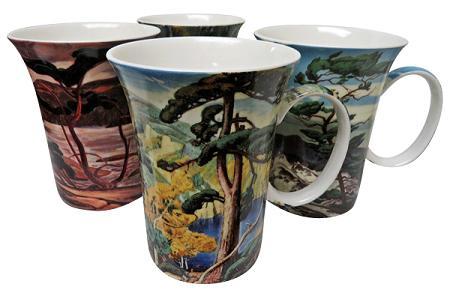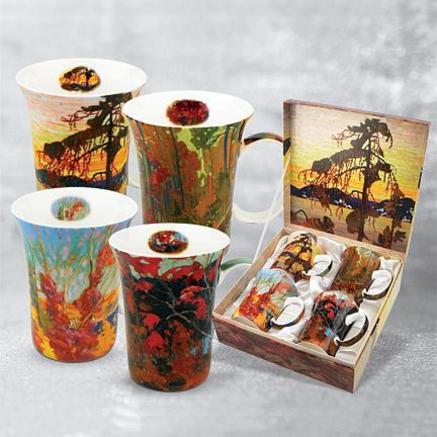The first image is the image on the left, the second image is the image on the right. For the images shown, is this caption "Four mugs sit in a case while four sit outside the case in the image on the right." true? Answer yes or no. Yes. 